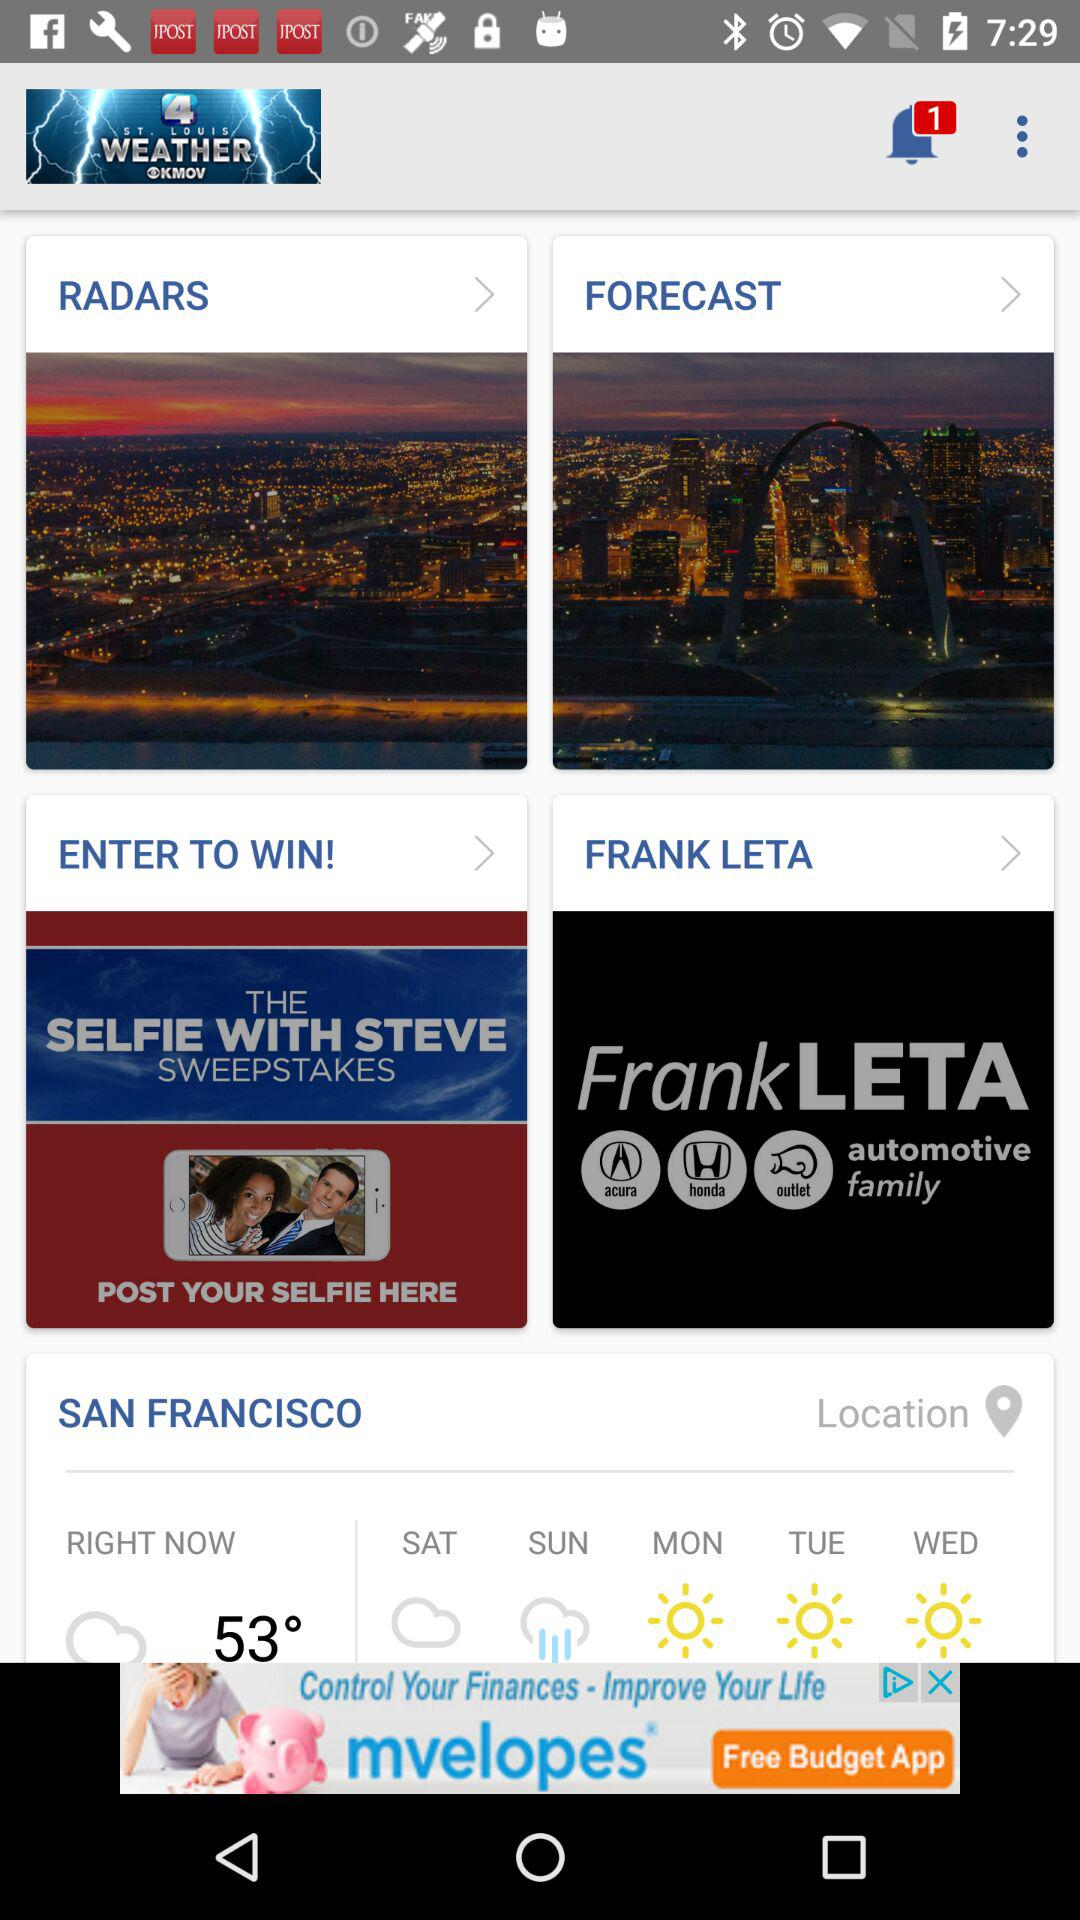How many notifications are unread? There is 1 unread notification. 